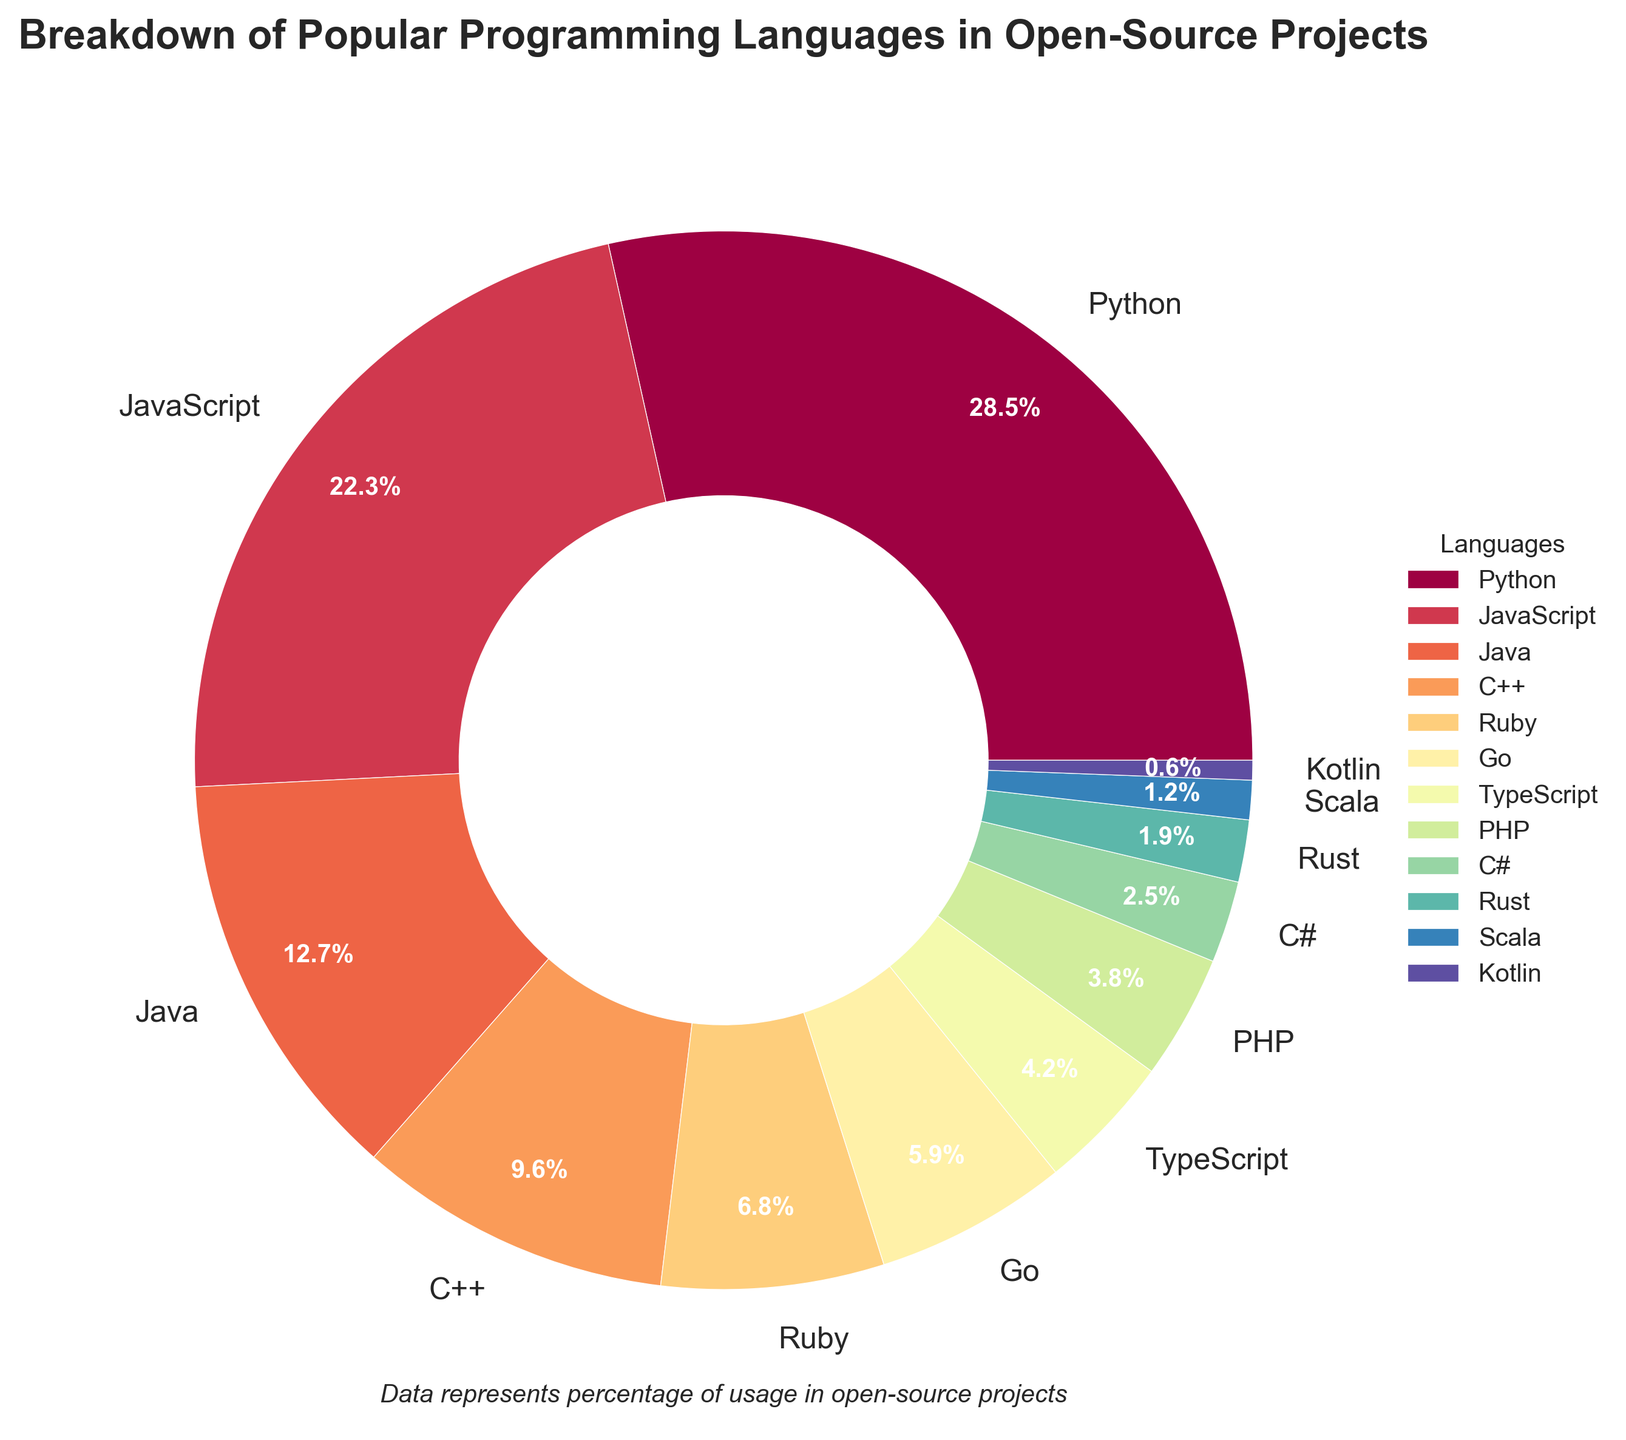Which programming language has the highest percentage in open-source projects? The language with the highest percentage is the one with the largest slice of the pie chart. From the figure, we see that Python has the largest slice.
Answer: Python What is the combined percentage of Python and JavaScript in open-source projects? To find the combined percentage, add the percentages of Python and JavaScript. From the figure, Python is 28.5% and JavaScript is 22.3%. Summing them gives 28.5 + 22.3 = 50.8%.
Answer: 50.8% Among the languages C++, Ruby, and Go, which one has the smallest percentage? Compare the slices representing C++ (9.6%), Ruby (6.8%), and Go (5.9%). The smallest slice represents Go.
Answer: Go What is the difference in percentage usage between Java and C#? Subtract the percentage of C# from the percentage of Java. From the figure, Java is 12.7% and C# is 2.5%. Performing the subtraction, 12.7 - 2.5 = 10.2%.
Answer: 10.2% Out of the languages listed, which one falls below the 2% threshold? Check the slices for percentages below 2%. From the figure, Rust (1.9%), Scala (1.2%), and Kotlin (0.6%) fall below 2%.
Answer: Rust, Scala, Kotlin How does the percentage of TypeScript compare to PHP? Compare the slices for TypeScript (4.2%) and PHP (3.8%). TypeScript has a higher percentage than PHP.
Answer: TypeScript > PHP If you sum up the percentages of all languages with more than 10% usage, what value do you get? Sum the percentages of languages with more than 10%. From the figure, Python (28.5%), JavaScript (22.3%), and Java (12.7%) fall into this category. The combined sum is 28.5 + 22.3 + 12.7 = 63.5%.
Answer: 63.5% Which languages are represented by the warmest colors in the figure? Identify the slices colored in red, orange, or yellow tones. From the figure, Python, JavaScript, and Java appear in the warmest colors.
Answer: Python, JavaScript, Java 